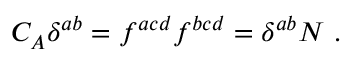<formula> <loc_0><loc_0><loc_500><loc_500>C _ { A } \delta ^ { a b } = f ^ { a c d } f ^ { b c d } = \delta ^ { a b } N \ .</formula> 